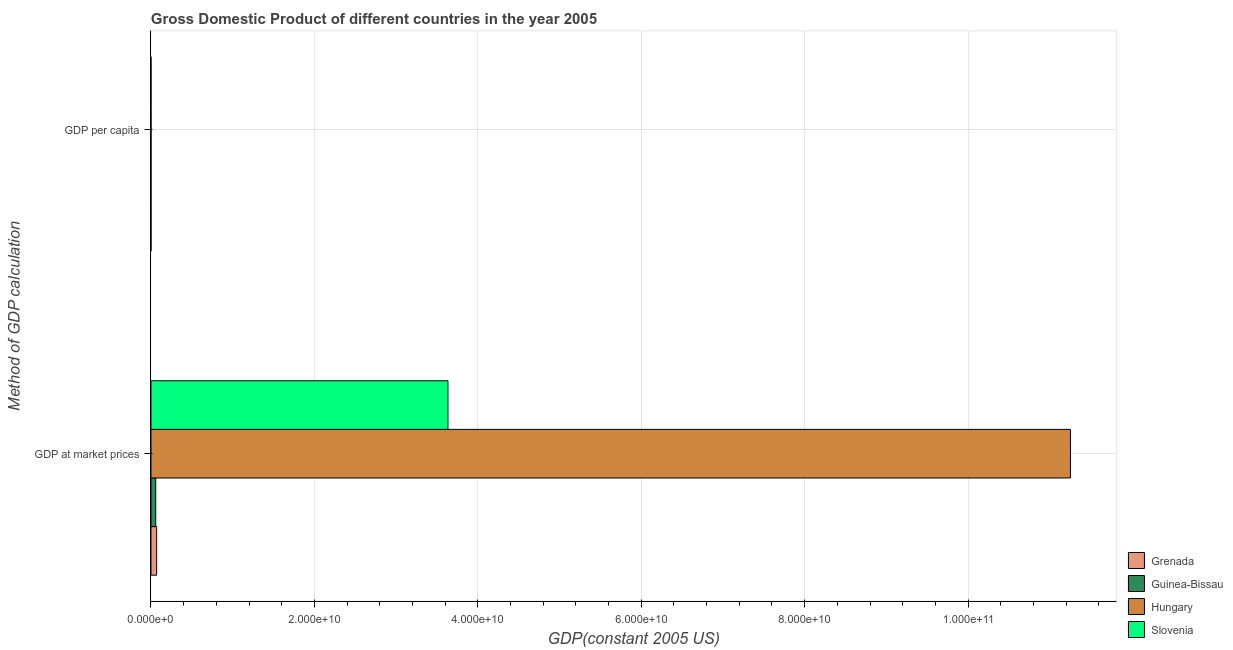How many different coloured bars are there?
Offer a terse response. 4. Are the number of bars on each tick of the Y-axis equal?
Provide a short and direct response. Yes. What is the label of the 2nd group of bars from the top?
Provide a succinct answer. GDP at market prices. What is the gdp per capita in Grenada?
Make the answer very short. 6754.38. Across all countries, what is the maximum gdp at market prices?
Your response must be concise. 1.13e+11. Across all countries, what is the minimum gdp at market prices?
Make the answer very short. 5.87e+08. In which country was the gdp at market prices maximum?
Offer a very short reply. Hungary. In which country was the gdp at market prices minimum?
Keep it short and to the point. Guinea-Bissau. What is the total gdp per capita in the graph?
Provide a succinct answer. 3.65e+04. What is the difference between the gdp per capita in Hungary and that in Slovenia?
Provide a short and direct response. -7013.22. What is the difference between the gdp per capita in Slovenia and the gdp at market prices in Guinea-Bissau?
Make the answer very short. -5.87e+08. What is the average gdp per capita per country?
Offer a very short reply. 9120.17. What is the difference between the gdp at market prices and gdp per capita in Grenada?
Offer a very short reply. 6.95e+08. In how many countries, is the gdp per capita greater than 92000000000 US$?
Your answer should be very brief. 0. What is the ratio of the gdp per capita in Grenada to that in Guinea-Bissau?
Keep it short and to the point. 16.84. What does the 1st bar from the top in GDP per capita represents?
Give a very brief answer. Slovenia. What does the 3rd bar from the bottom in GDP at market prices represents?
Offer a very short reply. Hungary. How many countries are there in the graph?
Give a very brief answer. 4. Are the values on the major ticks of X-axis written in scientific E-notation?
Keep it short and to the point. Yes. Does the graph contain grids?
Give a very brief answer. Yes. What is the title of the graph?
Offer a terse response. Gross Domestic Product of different countries in the year 2005. Does "Eritrea" appear as one of the legend labels in the graph?
Provide a short and direct response. No. What is the label or title of the X-axis?
Give a very brief answer. GDP(constant 2005 US). What is the label or title of the Y-axis?
Your answer should be compact. Method of GDP calculation. What is the GDP(constant 2005 US) of Grenada in GDP at market prices?
Make the answer very short. 6.95e+08. What is the GDP(constant 2005 US) in Guinea-Bissau in GDP at market prices?
Your answer should be very brief. 5.87e+08. What is the GDP(constant 2005 US) in Hungary in GDP at market prices?
Your response must be concise. 1.13e+11. What is the GDP(constant 2005 US) in Slovenia in GDP at market prices?
Make the answer very short. 3.63e+1. What is the GDP(constant 2005 US) in Grenada in GDP per capita?
Provide a succinct answer. 6754.38. What is the GDP(constant 2005 US) of Guinea-Bissau in GDP per capita?
Keep it short and to the point. 401.15. What is the GDP(constant 2005 US) of Hungary in GDP per capita?
Give a very brief answer. 1.12e+04. What is the GDP(constant 2005 US) in Slovenia in GDP per capita?
Your answer should be compact. 1.82e+04. Across all Method of GDP calculation, what is the maximum GDP(constant 2005 US) in Grenada?
Make the answer very short. 6.95e+08. Across all Method of GDP calculation, what is the maximum GDP(constant 2005 US) in Guinea-Bissau?
Offer a terse response. 5.87e+08. Across all Method of GDP calculation, what is the maximum GDP(constant 2005 US) in Hungary?
Make the answer very short. 1.13e+11. Across all Method of GDP calculation, what is the maximum GDP(constant 2005 US) in Slovenia?
Your response must be concise. 3.63e+1. Across all Method of GDP calculation, what is the minimum GDP(constant 2005 US) of Grenada?
Your response must be concise. 6754.38. Across all Method of GDP calculation, what is the minimum GDP(constant 2005 US) in Guinea-Bissau?
Ensure brevity in your answer.  401.15. Across all Method of GDP calculation, what is the minimum GDP(constant 2005 US) of Hungary?
Provide a succinct answer. 1.12e+04. Across all Method of GDP calculation, what is the minimum GDP(constant 2005 US) in Slovenia?
Make the answer very short. 1.82e+04. What is the total GDP(constant 2005 US) in Grenada in the graph?
Provide a short and direct response. 6.95e+08. What is the total GDP(constant 2005 US) of Guinea-Bissau in the graph?
Ensure brevity in your answer.  5.87e+08. What is the total GDP(constant 2005 US) of Hungary in the graph?
Your answer should be very brief. 1.13e+11. What is the total GDP(constant 2005 US) of Slovenia in the graph?
Keep it short and to the point. 3.63e+1. What is the difference between the GDP(constant 2005 US) of Grenada in GDP at market prices and that in GDP per capita?
Keep it short and to the point. 6.95e+08. What is the difference between the GDP(constant 2005 US) of Guinea-Bissau in GDP at market prices and that in GDP per capita?
Offer a very short reply. 5.87e+08. What is the difference between the GDP(constant 2005 US) of Hungary in GDP at market prices and that in GDP per capita?
Offer a terse response. 1.13e+11. What is the difference between the GDP(constant 2005 US) in Slovenia in GDP at market prices and that in GDP per capita?
Your answer should be very brief. 3.63e+1. What is the difference between the GDP(constant 2005 US) in Grenada in GDP at market prices and the GDP(constant 2005 US) in Guinea-Bissau in GDP per capita?
Keep it short and to the point. 6.95e+08. What is the difference between the GDP(constant 2005 US) of Grenada in GDP at market prices and the GDP(constant 2005 US) of Hungary in GDP per capita?
Provide a short and direct response. 6.95e+08. What is the difference between the GDP(constant 2005 US) in Grenada in GDP at market prices and the GDP(constant 2005 US) in Slovenia in GDP per capita?
Provide a succinct answer. 6.95e+08. What is the difference between the GDP(constant 2005 US) of Guinea-Bissau in GDP at market prices and the GDP(constant 2005 US) of Hungary in GDP per capita?
Make the answer very short. 5.87e+08. What is the difference between the GDP(constant 2005 US) in Guinea-Bissau in GDP at market prices and the GDP(constant 2005 US) in Slovenia in GDP per capita?
Your answer should be compact. 5.87e+08. What is the difference between the GDP(constant 2005 US) of Hungary in GDP at market prices and the GDP(constant 2005 US) of Slovenia in GDP per capita?
Make the answer very short. 1.13e+11. What is the average GDP(constant 2005 US) in Grenada per Method of GDP calculation?
Provide a succinct answer. 3.48e+08. What is the average GDP(constant 2005 US) of Guinea-Bissau per Method of GDP calculation?
Provide a short and direct response. 2.93e+08. What is the average GDP(constant 2005 US) of Hungary per Method of GDP calculation?
Offer a very short reply. 5.63e+1. What is the average GDP(constant 2005 US) in Slovenia per Method of GDP calculation?
Offer a terse response. 1.82e+1. What is the difference between the GDP(constant 2005 US) of Grenada and GDP(constant 2005 US) of Guinea-Bissau in GDP at market prices?
Your answer should be compact. 1.09e+08. What is the difference between the GDP(constant 2005 US) in Grenada and GDP(constant 2005 US) in Hungary in GDP at market prices?
Your response must be concise. -1.12e+11. What is the difference between the GDP(constant 2005 US) in Grenada and GDP(constant 2005 US) in Slovenia in GDP at market prices?
Offer a terse response. -3.57e+1. What is the difference between the GDP(constant 2005 US) of Guinea-Bissau and GDP(constant 2005 US) of Hungary in GDP at market prices?
Offer a very short reply. -1.12e+11. What is the difference between the GDP(constant 2005 US) of Guinea-Bissau and GDP(constant 2005 US) of Slovenia in GDP at market prices?
Offer a very short reply. -3.58e+1. What is the difference between the GDP(constant 2005 US) in Hungary and GDP(constant 2005 US) in Slovenia in GDP at market prices?
Make the answer very short. 7.62e+1. What is the difference between the GDP(constant 2005 US) of Grenada and GDP(constant 2005 US) of Guinea-Bissau in GDP per capita?
Ensure brevity in your answer.  6353.23. What is the difference between the GDP(constant 2005 US) in Grenada and GDP(constant 2005 US) in Hungary in GDP per capita?
Your answer should be compact. -4401.58. What is the difference between the GDP(constant 2005 US) in Grenada and GDP(constant 2005 US) in Slovenia in GDP per capita?
Give a very brief answer. -1.14e+04. What is the difference between the GDP(constant 2005 US) in Guinea-Bissau and GDP(constant 2005 US) in Hungary in GDP per capita?
Ensure brevity in your answer.  -1.08e+04. What is the difference between the GDP(constant 2005 US) in Guinea-Bissau and GDP(constant 2005 US) in Slovenia in GDP per capita?
Provide a succinct answer. -1.78e+04. What is the difference between the GDP(constant 2005 US) of Hungary and GDP(constant 2005 US) of Slovenia in GDP per capita?
Provide a succinct answer. -7013.22. What is the ratio of the GDP(constant 2005 US) in Grenada in GDP at market prices to that in GDP per capita?
Your answer should be very brief. 1.03e+05. What is the ratio of the GDP(constant 2005 US) in Guinea-Bissau in GDP at market prices to that in GDP per capita?
Give a very brief answer. 1.46e+06. What is the ratio of the GDP(constant 2005 US) in Hungary in GDP at market prices to that in GDP per capita?
Ensure brevity in your answer.  1.01e+07. What is the ratio of the GDP(constant 2005 US) of Slovenia in GDP at market prices to that in GDP per capita?
Your answer should be compact. 2.00e+06. What is the difference between the highest and the second highest GDP(constant 2005 US) of Grenada?
Your answer should be compact. 6.95e+08. What is the difference between the highest and the second highest GDP(constant 2005 US) of Guinea-Bissau?
Keep it short and to the point. 5.87e+08. What is the difference between the highest and the second highest GDP(constant 2005 US) of Hungary?
Keep it short and to the point. 1.13e+11. What is the difference between the highest and the second highest GDP(constant 2005 US) of Slovenia?
Ensure brevity in your answer.  3.63e+1. What is the difference between the highest and the lowest GDP(constant 2005 US) of Grenada?
Offer a very short reply. 6.95e+08. What is the difference between the highest and the lowest GDP(constant 2005 US) in Guinea-Bissau?
Make the answer very short. 5.87e+08. What is the difference between the highest and the lowest GDP(constant 2005 US) of Hungary?
Offer a very short reply. 1.13e+11. What is the difference between the highest and the lowest GDP(constant 2005 US) of Slovenia?
Your response must be concise. 3.63e+1. 